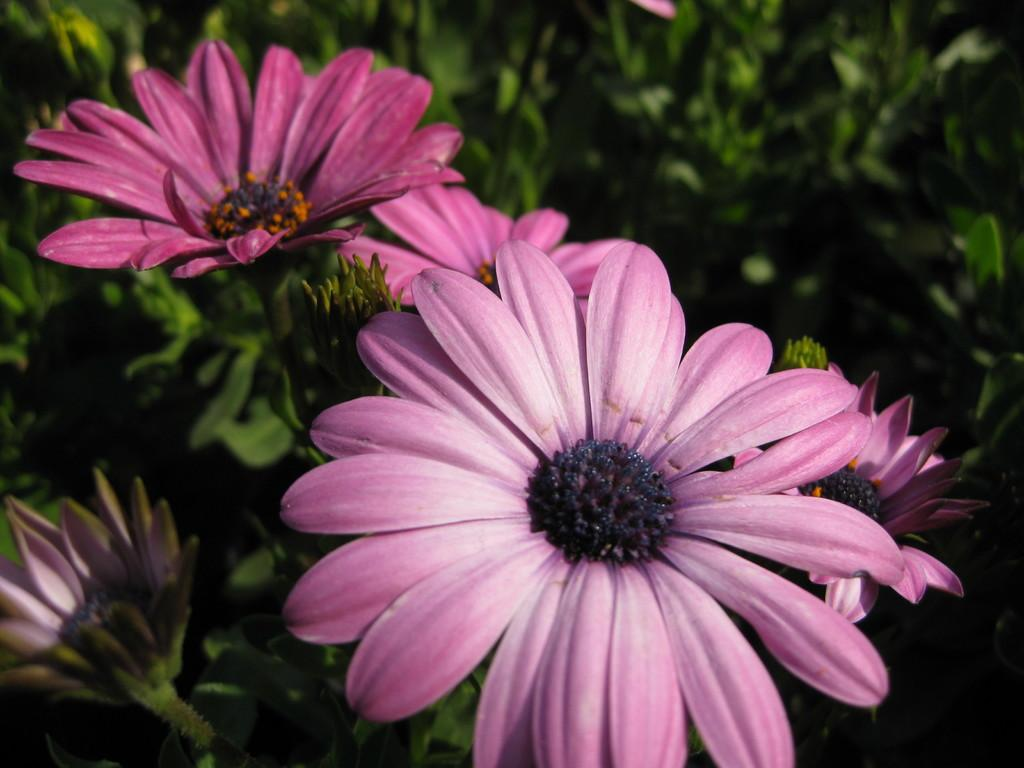What type of plants can be seen in the image? There are flowers in the image. What stage of growth are the plants in the image? There are buds on the plants in the image. What type of rhythm can be heard coming from the apples in the image? There are no apples present in the image, and therefore no rhythm can be heard from them. 